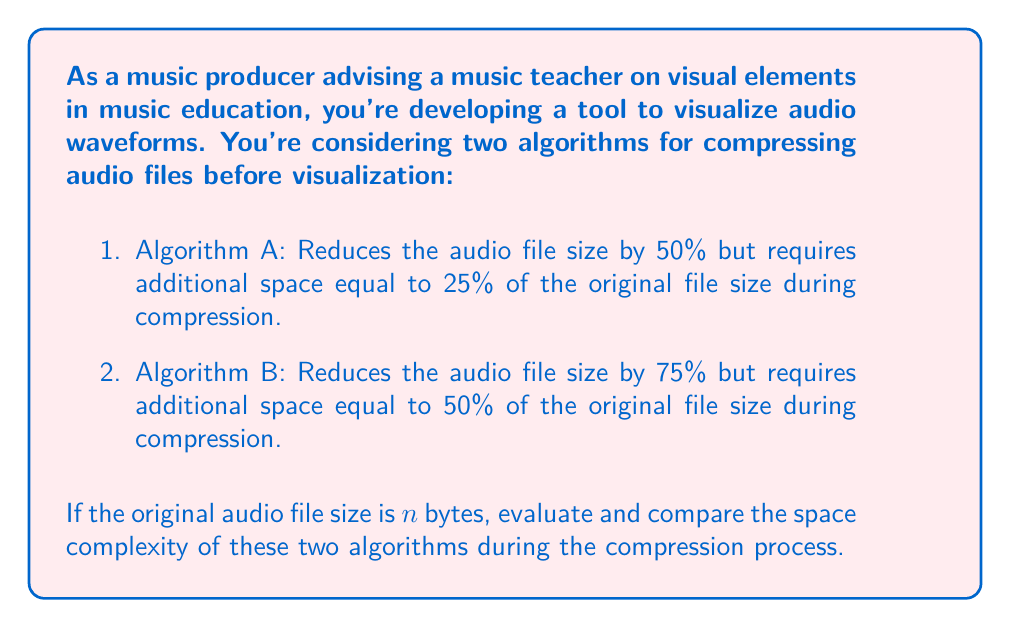Help me with this question. To evaluate the space complexity of these algorithms, we need to consider the maximum amount of space required during the compression process. This includes both the original file and any additional space needed for compression.

For Algorithm A:
1. Original file size: $n$ bytes
2. Additional space required: $0.25n$ bytes
3. Total space during compression: $n + 0.25n = 1.25n$ bytes
4. Space complexity: $O(n)$

For Algorithm B:
1. Original file size: $n$ bytes
2. Additional space required: $0.5n$ bytes
3. Total space during compression: $n + 0.5n = 1.5n$ bytes
4. Space complexity: $O(n)$

Both algorithms have a linear space complexity of $O(n)$ with respect to the input size. However, Algorithm B requires more space during the compression process (1.5n vs 1.25n).

It's worth noting that after compression:
- Algorithm A will result in a file of size $0.5n$ bytes
- Algorithm B will result in a file of size $0.25n$ bytes

This post-compression size difference might be relevant for long-term storage or transmission, but it doesn't affect the space complexity during the compression process.
Answer: Both Algorithm A and Algorithm B have a space complexity of $O(n)$, where $n$ is the size of the original audio file in bytes. However, Algorithm B requires more space during the compression process, using $1.5n$ bytes compared to Algorithm A's $1.25n$ bytes. 